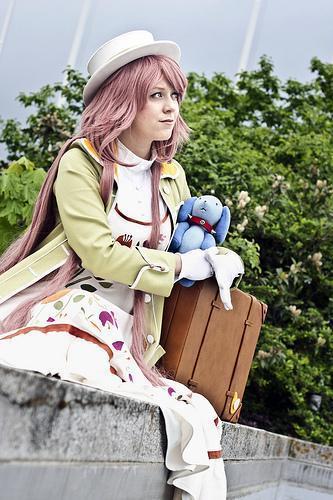How many people are shown?
Give a very brief answer. 1. 